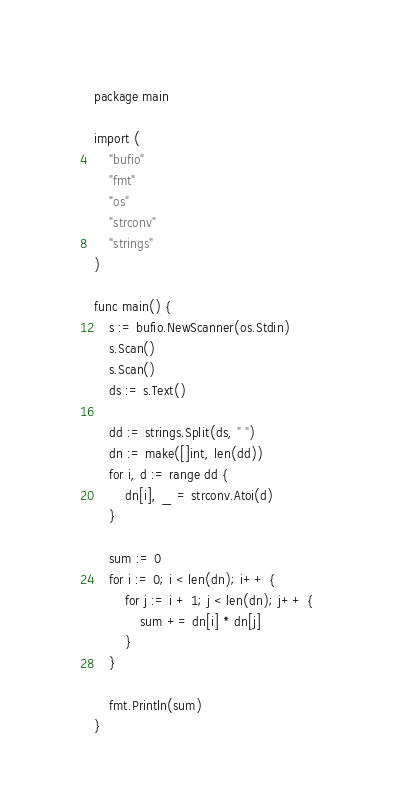Convert code to text. <code><loc_0><loc_0><loc_500><loc_500><_Go_>package main

import (
	"bufio"
	"fmt"
	"os"
	"strconv"
	"strings"
)

func main() {
	s := bufio.NewScanner(os.Stdin)
	s.Scan()
	s.Scan()
	ds := s.Text()

	dd := strings.Split(ds, " ")
	dn := make([]int, len(dd))
	for i, d := range dd {
		dn[i], _ = strconv.Atoi(d)
	}

	sum := 0
	for i := 0; i < len(dn); i++ {
		for j := i + 1; j < len(dn); j++ {
			sum += dn[i] * dn[j]
		}
	}

	fmt.Println(sum)
}
</code> 